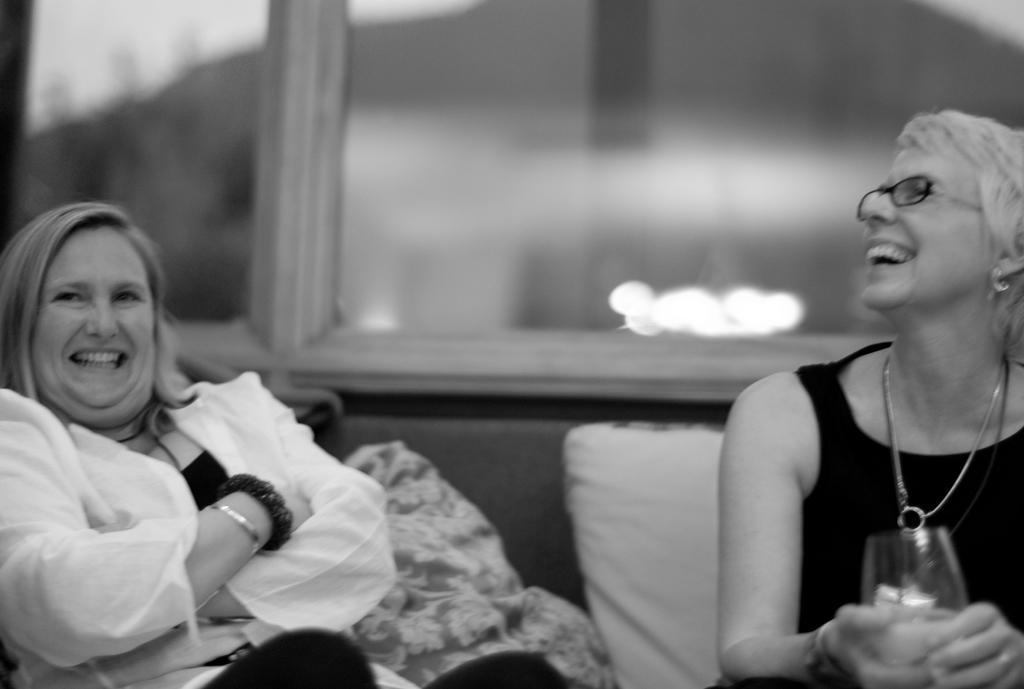In one or two sentences, can you explain what this image depicts? In this image there are two ladies sitting on the sofa. The lady sitting on the right is holding a glass. There are cushions placed on the sofa. In the background there is a window. 